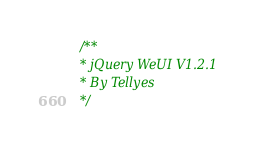<code> <loc_0><loc_0><loc_500><loc_500><_CSS_>/** 
* jQuery WeUI V1.2.1 
* By Tellyes
*/</code> 